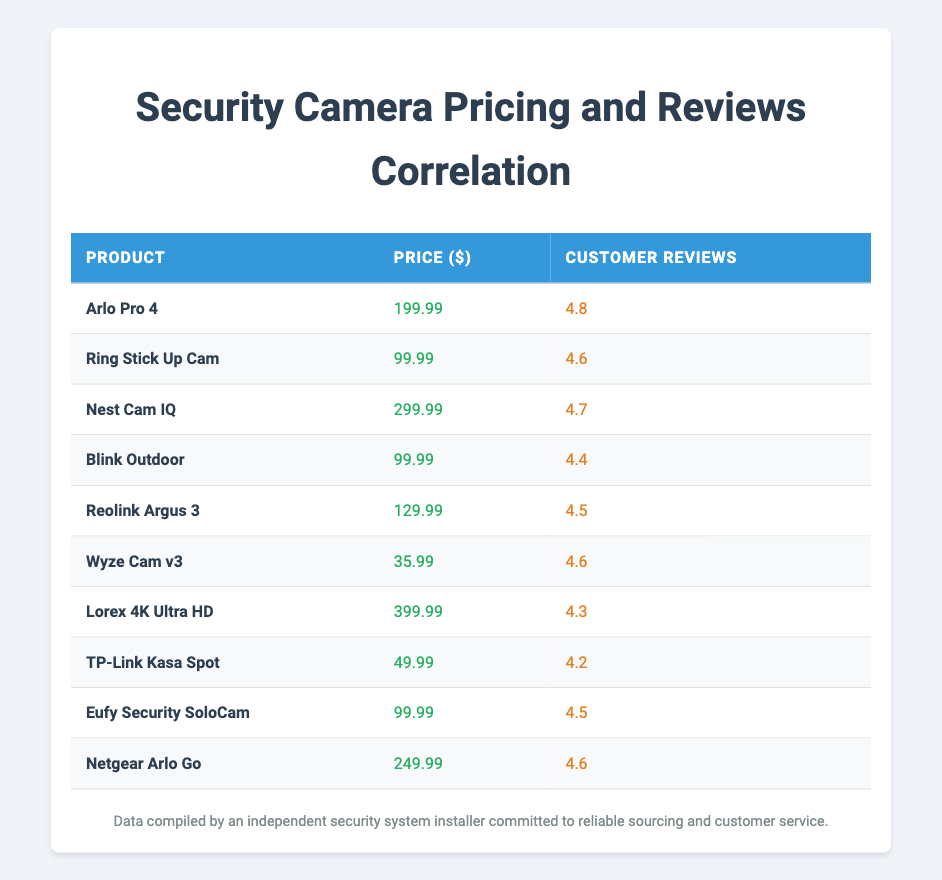What is the price of the Wyze Cam v3? The table shows that the price of the Wyze Cam v3 is listed directly in the price column, which is 35.99.
Answer: 35.99 Which security camera has the highest customer reviews? According to the customer reviews column, the Arlo Pro 4 has the highest rating of 4.8, which is the highest value when compared to all other products listed.
Answer: Arlo Pro 4 What is the average price of the security cameras listed? To calculate the average price, I sum all the prices: (199.99 + 99.99 + 299.99 + 99.99 + 129.99 + 35.99 + 399.99 + 49.99 + 99.99 + 249.99) = 1554.90. There are 10 products, so the average price is 1554.90 / 10 = 155.49.
Answer: 155.49 Is there a camera priced over 300 dollars? By reviewing the price column, I see that both the Nest Cam IQ (299.99) and Lorex 4K Ultra HD (399.99) are present, with Lorex being the only one over 300 dollars. Therefore, there is a camera priced over 300.00.
Answer: Yes What is the customer review difference between the most expensive and the least expensive camera? First, I identify the most expensive camera, which is Lorex 4K Ultra HD at 399.99 with a review of 4.3. The least expensive is Wyze Cam v3 at 35.99 with a review of 4.6. The difference is 4.6 - 4.3 = 0.3.
Answer: 0.3 Which cameras have customer reviews of 4.5 or higher and are priced under 150 dollars? Checking the customer reviews, the cameras that meet this condition are: Reolink Argus 3 priced at 129.99 with a review of 4.5 and Eufy Security SoloCam priced at 99.99 with a review of 4.5. These are the only two that meet both price and review criteria.
Answer: Reolink Argus 3, Eufy Security SoloCam How many security cameras have customer reviews lower than 4.5? Upon inspection of the customer reviews column, I see that there are two cameras with reviews lower than 4.5: Blink Outdoor (4.4) and Lorex 4K Ultra HD (4.3), leading to a total count of 2.
Answer: 2 What is the relationship between price and customer reviews for the cameras listed? Analyzing the data, I see that higher priced cameras tend to have higher customer reviews but there are exceptions, such as the Wyze Cam v3 at a low price with a good review. This highlights that price doesn’t always dictate customer satisfaction.
Answer: High price tends to correlate with high reviews, but exceptions exist What is the range of customer reviews among the cameras listed? First, I identify the highest review (Arlo Pro 4 at 4.8) and the lowest (Lorex 4K Ultra HD at 4.3). The range is calculated by subtracting the lowest from the highest: 4.8 - 4.3 = 0.5.
Answer: 0.5 